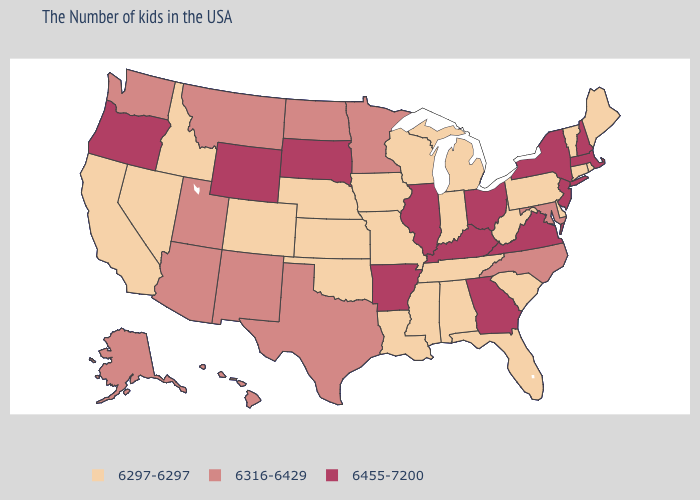Which states have the lowest value in the USA?
Give a very brief answer. Maine, Rhode Island, Vermont, Connecticut, Delaware, Pennsylvania, South Carolina, West Virginia, Florida, Michigan, Indiana, Alabama, Tennessee, Wisconsin, Mississippi, Louisiana, Missouri, Iowa, Kansas, Nebraska, Oklahoma, Colorado, Idaho, Nevada, California. Does Alabama have the lowest value in the South?
Concise answer only. Yes. Which states have the highest value in the USA?
Concise answer only. Massachusetts, New Hampshire, New York, New Jersey, Virginia, Ohio, Georgia, Kentucky, Illinois, Arkansas, South Dakota, Wyoming, Oregon. Does the first symbol in the legend represent the smallest category?
Keep it brief. Yes. Does Arizona have the highest value in the West?
Give a very brief answer. No. What is the value of Utah?
Be succinct. 6316-6429. Name the states that have a value in the range 6316-6429?
Keep it brief. Maryland, North Carolina, Minnesota, Texas, North Dakota, New Mexico, Utah, Montana, Arizona, Washington, Alaska, Hawaii. Name the states that have a value in the range 6297-6297?
Give a very brief answer. Maine, Rhode Island, Vermont, Connecticut, Delaware, Pennsylvania, South Carolina, West Virginia, Florida, Michigan, Indiana, Alabama, Tennessee, Wisconsin, Mississippi, Louisiana, Missouri, Iowa, Kansas, Nebraska, Oklahoma, Colorado, Idaho, Nevada, California. What is the value of Alabama?
Concise answer only. 6297-6297. What is the lowest value in states that border South Carolina?
Give a very brief answer. 6316-6429. What is the value of Virginia?
Keep it brief. 6455-7200. Among the states that border West Virginia , does Pennsylvania have the lowest value?
Short answer required. Yes. What is the value of Illinois?
Be succinct. 6455-7200. Does Nevada have the highest value in the USA?
Be succinct. No. Name the states that have a value in the range 6455-7200?
Answer briefly. Massachusetts, New Hampshire, New York, New Jersey, Virginia, Ohio, Georgia, Kentucky, Illinois, Arkansas, South Dakota, Wyoming, Oregon. 